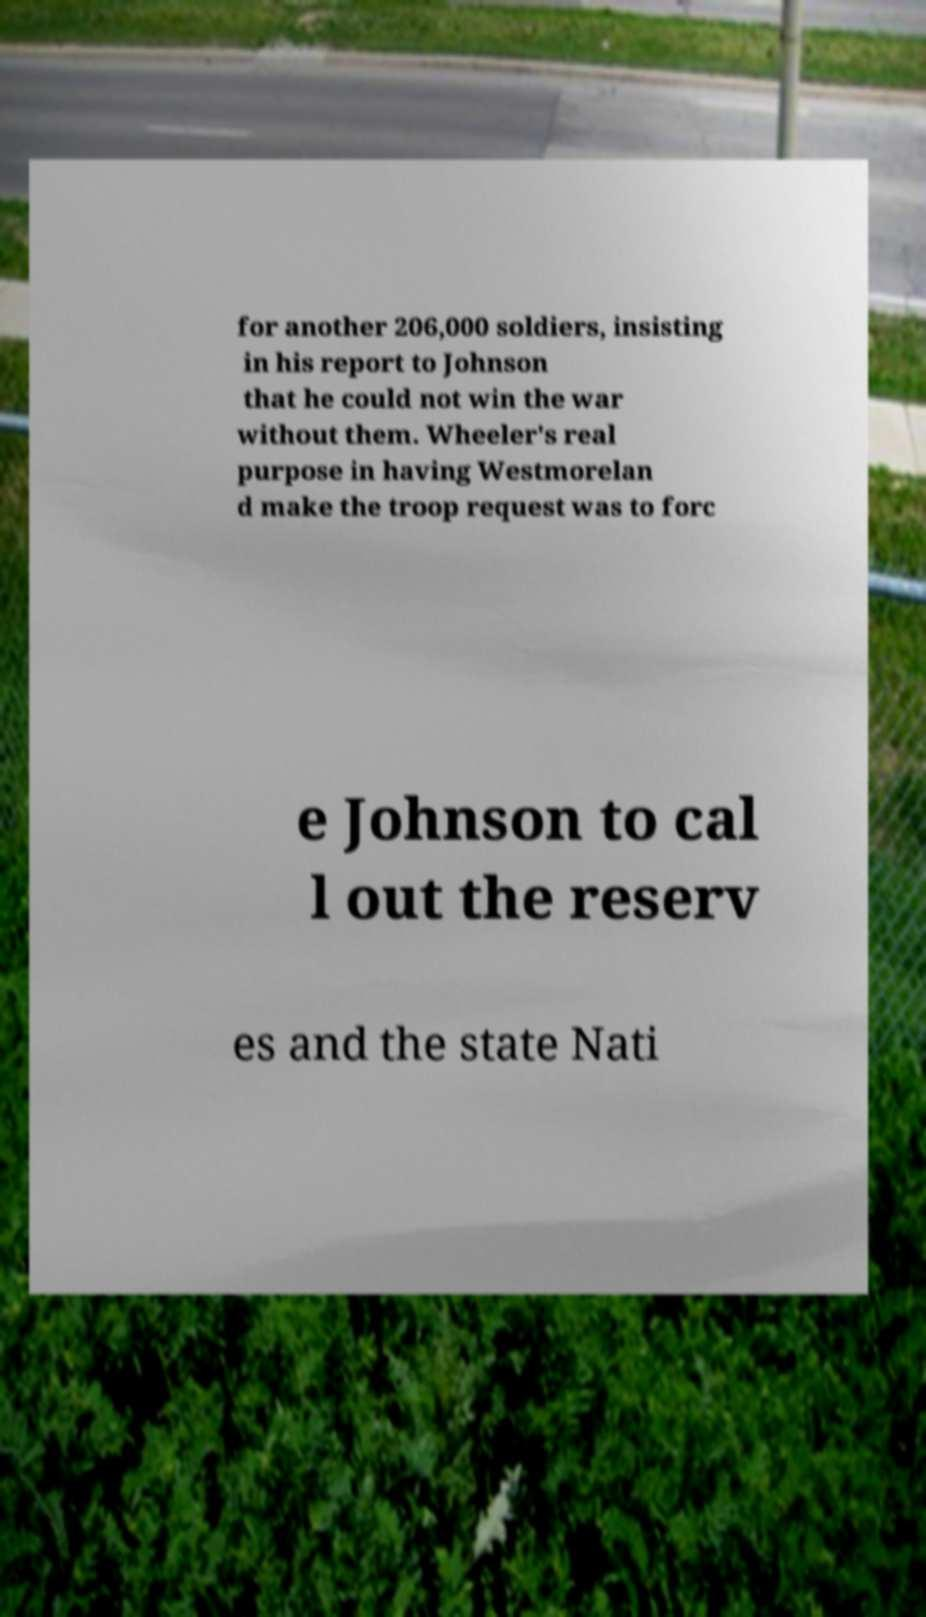For documentation purposes, I need the text within this image transcribed. Could you provide that? for another 206,000 soldiers, insisting in his report to Johnson that he could not win the war without them. Wheeler's real purpose in having Westmorelan d make the troop request was to forc e Johnson to cal l out the reserv es and the state Nati 